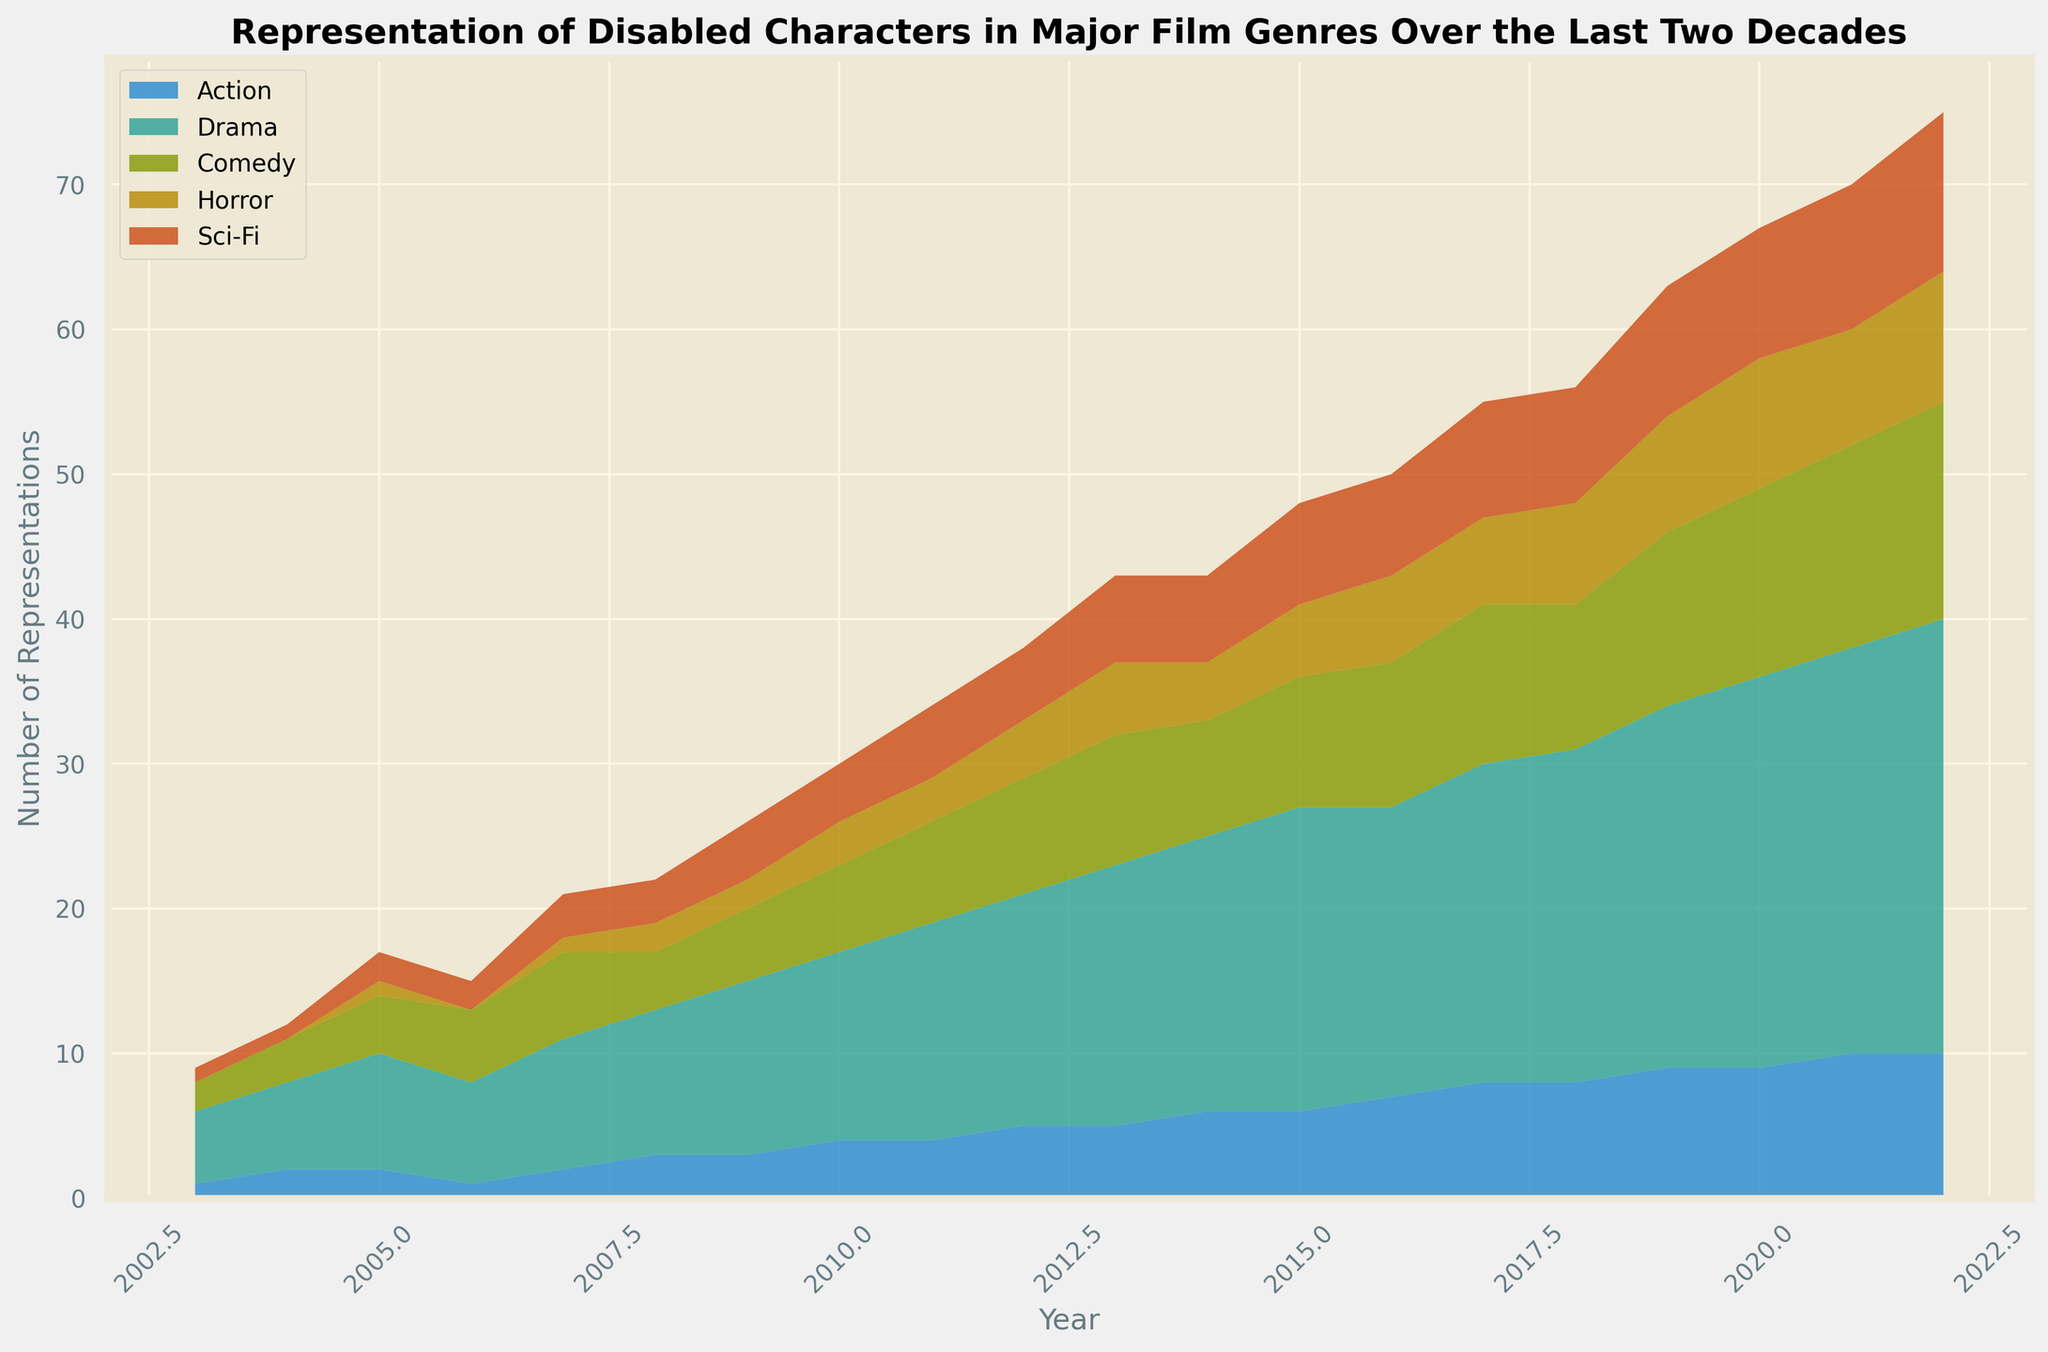Which genre saw a consistent increase in the representation of disabled characters over the years? By looking at the data visually, it's clear that the Drama genre shows a consistent and noticeable increase in the representation of disabled characters over the years, with no significant dips.
Answer: Drama Between which years did the Sci-Fi genre see its greatest increase in representation of disabled characters? To find the largest increase, we need to look for the steepest incline in the Sci-Fi section of the area chart. From 2003 to 2022, the largest increase for Sci-Fi seems to be between 2007 and 2009 as the increase is more apparent visually in that interval.
Answer: 2007-2009 In which year did the Comedy genre surpass the Horror genre in the representation figures? By examining the chart, we can see where the Comedy area becomes visually larger than the Horror area. This crossover appears to happen around the year 2005.
Answer: 2005 How many genres showed a decline in representation from 2021 to 2022? By evaluating the shapes for all genres between these years, we see that none of the genres show a decline from 2021 to 2022; they all either increase or stay the same.
Answer: 0 What is the total representation of disabled characters in the year 2018? The total representation is the sum of the values for all genres in 2018: Action (8) + Drama (23) + Comedy (10) + Horror (7) + Sci-Fi (8) = 56.
Answer: 56 Compare the total representations in 2003 and 2022. Which year had a higher count, and by how much? We calculate the totals for both years and then compare: 2003 (1+5+2+0+1 = 9) and 2022 (10+30+15+9+11 = 75). 2022 had a higher count by 75 - 9 = 66.
Answer: 2022 by 66 During which period did the Action genre representation plateau? The chart shows the Action genre's area visually flat. We see a plateau from 2010 to 2011.
Answer: 2010-2011 Which genre has the most significant visually observable fluctuation over the years? By checking the ups and downs in the filled areas, the Drama genre stands out with the most visually observable fluctuation due to its dynamic increase.
Answer: Drama What is the average annual representation for the Horror genre across all years? Sum up the yearly values for Horror and divide by the number of years: (0+0+1+0+1+2+2+3+3+4+5+4+5+6+6+7+8+9) / 20 = 4.
Answer: 4 